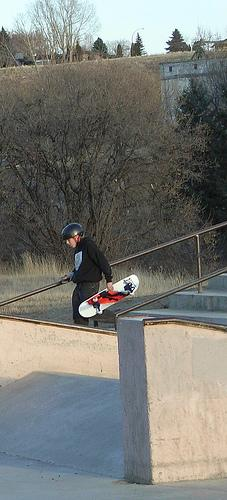Convey the main idea of the image, detailing the important elements like the person, their attire, and their activity. A helmeted boy is seen walking down a series of steps, holding onto his vividly colored skateboard, and wearing a black hooded garment. Narrate the scenario taking place in the image, including details about the subject and the surroundings. Amidst a backdrop of trees and buildings, a young skateboarder descends a flight of stairs with a skateboard in hand, donning a helmet and a black sweater. Mention the key subject, their attire, and their action in the image. A boy wearing a black sweater and helmet is walking down stairs while holding a red, blue, and white skateboard. Paint a picture of the scene in the image, including the central focus and the general atmosphere. The image depicts a youthful skateboarder in a protective helmet and black attire, strolling down a staircase against a backdrop of buildings and foliage. Provide a brief overview of the central character, their attire, and the primary event transpiring in the image. A young individual wearing a black hoodie and helmet is seen descending steps, holding a colorful skateboard in their hand. Describe the location of the image and the activity the main character is engaged in. At a hilltop location with buildings and trees, a boy is descending a staircase holding a skateboard and wearing a helmet. Elaborate on the main person in the image along with their clothing and actions. A skateboarder, clad in a black helmet and hoodie, is making his way down a staircase while securely grasping his red, blue, and white skateboard. Briefly describe the scene in the image, including the setting and the main action taking place. In an outdoor setting with trees, a boy is walking down a concrete staircase with a skateboard in hand and wearing safety gear. Describe the primary subject of the image and their current action, in addition to any notable attire. The image shows a boy donned in a black sweater and helmet, holding a skateboard while descending a staircase. Sum up the scene in the image, focusing on the main person, their clothing and the situation they are involved in. In a serene outdoor location, a boy in a black hoodie and helmet is carrying a skateboard and making his way down a flight of stairs. 